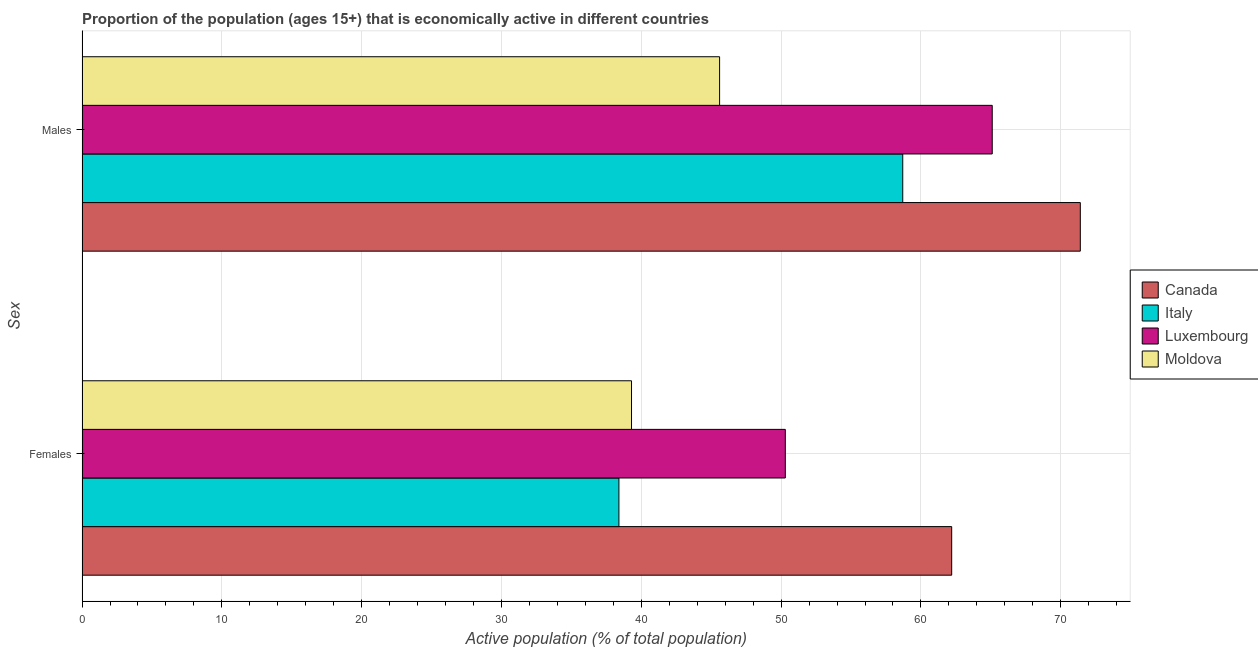How many different coloured bars are there?
Give a very brief answer. 4. Are the number of bars on each tick of the Y-axis equal?
Your answer should be compact. Yes. How many bars are there on the 1st tick from the bottom?
Your answer should be very brief. 4. What is the label of the 2nd group of bars from the top?
Keep it short and to the point. Females. What is the percentage of economically active male population in Luxembourg?
Make the answer very short. 65.1. Across all countries, what is the maximum percentage of economically active male population?
Keep it short and to the point. 71.4. Across all countries, what is the minimum percentage of economically active female population?
Your answer should be compact. 38.4. In which country was the percentage of economically active male population minimum?
Offer a very short reply. Moldova. What is the total percentage of economically active female population in the graph?
Offer a terse response. 190.2. What is the difference between the percentage of economically active male population in Italy and that in Moldova?
Provide a succinct answer. 13.1. What is the difference between the percentage of economically active female population in Luxembourg and the percentage of economically active male population in Moldova?
Offer a very short reply. 4.7. What is the average percentage of economically active male population per country?
Provide a succinct answer. 60.2. What is the difference between the percentage of economically active female population and percentage of economically active male population in Italy?
Ensure brevity in your answer.  -20.3. In how many countries, is the percentage of economically active male population greater than 52 %?
Keep it short and to the point. 3. What is the ratio of the percentage of economically active male population in Luxembourg to that in Moldova?
Keep it short and to the point. 1.43. What does the 4th bar from the top in Males represents?
Give a very brief answer. Canada. Are all the bars in the graph horizontal?
Offer a terse response. Yes. How many countries are there in the graph?
Keep it short and to the point. 4. What is the difference between two consecutive major ticks on the X-axis?
Your answer should be compact. 10. Are the values on the major ticks of X-axis written in scientific E-notation?
Offer a terse response. No. How many legend labels are there?
Offer a very short reply. 4. What is the title of the graph?
Your response must be concise. Proportion of the population (ages 15+) that is economically active in different countries. What is the label or title of the X-axis?
Ensure brevity in your answer.  Active population (% of total population). What is the label or title of the Y-axis?
Make the answer very short. Sex. What is the Active population (% of total population) of Canada in Females?
Offer a very short reply. 62.2. What is the Active population (% of total population) in Italy in Females?
Offer a very short reply. 38.4. What is the Active population (% of total population) in Luxembourg in Females?
Give a very brief answer. 50.3. What is the Active population (% of total population) in Moldova in Females?
Your response must be concise. 39.3. What is the Active population (% of total population) of Canada in Males?
Make the answer very short. 71.4. What is the Active population (% of total population) in Italy in Males?
Keep it short and to the point. 58.7. What is the Active population (% of total population) in Luxembourg in Males?
Provide a succinct answer. 65.1. What is the Active population (% of total population) in Moldova in Males?
Your answer should be compact. 45.6. Across all Sex, what is the maximum Active population (% of total population) of Canada?
Provide a short and direct response. 71.4. Across all Sex, what is the maximum Active population (% of total population) in Italy?
Ensure brevity in your answer.  58.7. Across all Sex, what is the maximum Active population (% of total population) in Luxembourg?
Offer a terse response. 65.1. Across all Sex, what is the maximum Active population (% of total population) in Moldova?
Offer a very short reply. 45.6. Across all Sex, what is the minimum Active population (% of total population) of Canada?
Your response must be concise. 62.2. Across all Sex, what is the minimum Active population (% of total population) of Italy?
Offer a terse response. 38.4. Across all Sex, what is the minimum Active population (% of total population) of Luxembourg?
Your answer should be very brief. 50.3. Across all Sex, what is the minimum Active population (% of total population) in Moldova?
Offer a very short reply. 39.3. What is the total Active population (% of total population) of Canada in the graph?
Offer a terse response. 133.6. What is the total Active population (% of total population) of Italy in the graph?
Make the answer very short. 97.1. What is the total Active population (% of total population) of Luxembourg in the graph?
Your answer should be very brief. 115.4. What is the total Active population (% of total population) in Moldova in the graph?
Your answer should be compact. 84.9. What is the difference between the Active population (% of total population) in Canada in Females and that in Males?
Offer a very short reply. -9.2. What is the difference between the Active population (% of total population) in Italy in Females and that in Males?
Make the answer very short. -20.3. What is the difference between the Active population (% of total population) of Luxembourg in Females and that in Males?
Offer a terse response. -14.8. What is the difference between the Active population (% of total population) of Moldova in Females and that in Males?
Make the answer very short. -6.3. What is the difference between the Active population (% of total population) of Canada in Females and the Active population (% of total population) of Italy in Males?
Your response must be concise. 3.5. What is the difference between the Active population (% of total population) in Canada in Females and the Active population (% of total population) in Moldova in Males?
Give a very brief answer. 16.6. What is the difference between the Active population (% of total population) in Italy in Females and the Active population (% of total population) in Luxembourg in Males?
Offer a very short reply. -26.7. What is the difference between the Active population (% of total population) of Italy in Females and the Active population (% of total population) of Moldova in Males?
Your answer should be compact. -7.2. What is the average Active population (% of total population) of Canada per Sex?
Give a very brief answer. 66.8. What is the average Active population (% of total population) in Italy per Sex?
Provide a succinct answer. 48.55. What is the average Active population (% of total population) of Luxembourg per Sex?
Keep it short and to the point. 57.7. What is the average Active population (% of total population) in Moldova per Sex?
Your answer should be compact. 42.45. What is the difference between the Active population (% of total population) of Canada and Active population (% of total population) of Italy in Females?
Provide a short and direct response. 23.8. What is the difference between the Active population (% of total population) of Canada and Active population (% of total population) of Luxembourg in Females?
Your answer should be compact. 11.9. What is the difference between the Active population (% of total population) in Canada and Active population (% of total population) in Moldova in Females?
Give a very brief answer. 22.9. What is the difference between the Active population (% of total population) of Italy and Active population (% of total population) of Moldova in Females?
Your answer should be very brief. -0.9. What is the difference between the Active population (% of total population) in Luxembourg and Active population (% of total population) in Moldova in Females?
Ensure brevity in your answer.  11. What is the difference between the Active population (% of total population) in Canada and Active population (% of total population) in Italy in Males?
Offer a terse response. 12.7. What is the difference between the Active population (% of total population) in Canada and Active population (% of total population) in Moldova in Males?
Keep it short and to the point. 25.8. What is the difference between the Active population (% of total population) of Italy and Active population (% of total population) of Luxembourg in Males?
Make the answer very short. -6.4. What is the ratio of the Active population (% of total population) in Canada in Females to that in Males?
Make the answer very short. 0.87. What is the ratio of the Active population (% of total population) of Italy in Females to that in Males?
Your response must be concise. 0.65. What is the ratio of the Active population (% of total population) of Luxembourg in Females to that in Males?
Offer a terse response. 0.77. What is the ratio of the Active population (% of total population) in Moldova in Females to that in Males?
Give a very brief answer. 0.86. What is the difference between the highest and the second highest Active population (% of total population) in Italy?
Keep it short and to the point. 20.3. What is the difference between the highest and the second highest Active population (% of total population) in Moldova?
Your response must be concise. 6.3. What is the difference between the highest and the lowest Active population (% of total population) of Canada?
Your response must be concise. 9.2. What is the difference between the highest and the lowest Active population (% of total population) of Italy?
Ensure brevity in your answer.  20.3. 